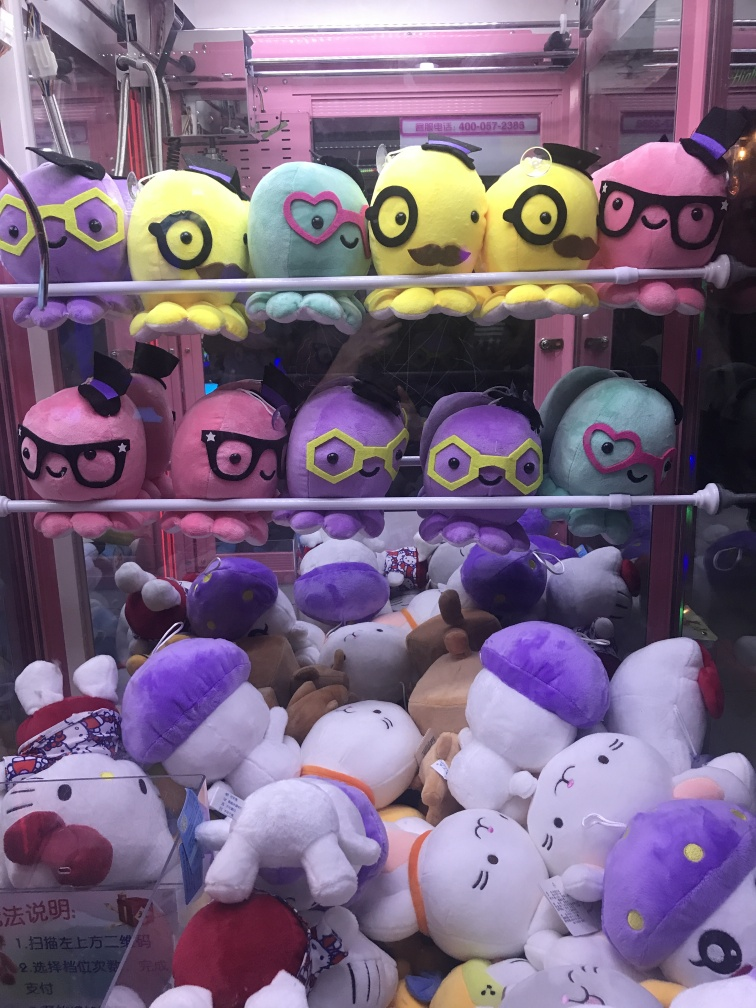Can you tell me more about the different plush toys in the machine? Certainly! The claw machine contains a delightful assortment of plush toys, with the upper row featuring stylized birds sporting whimsical glasses and hats, suggesting unique characters with a hint of personality. The bottom row is a cozy gathering of various other plush animals, from smiling bears to round-bodied rabbits, many of which are dressed up. A pirate-themed bear with a purple satin hat especially stands out. Each plush toy offers its own appeal through varied textures, colors, and costumes. 